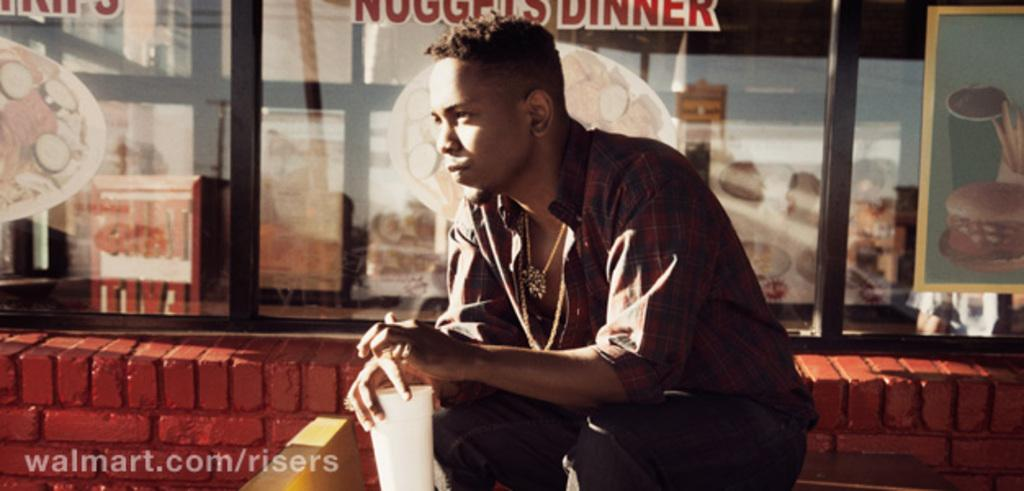What is the man in the image doing? The man is sitting in the center of the image. What is the man holding in the image? The man is holding a glass. What can be seen in the background of the image? There is a window in the background of the image. What is on the left side of the image? There is a wall on the left side of the image. What type of wristwatch can be seen on the man's wrist in the image? There is no wristwatch visible on the man's wrist in the image. Can you describe the action the man is performing with the glass in the image? The image does not show any specific action being performed with the glass; the man is simply holding it. 